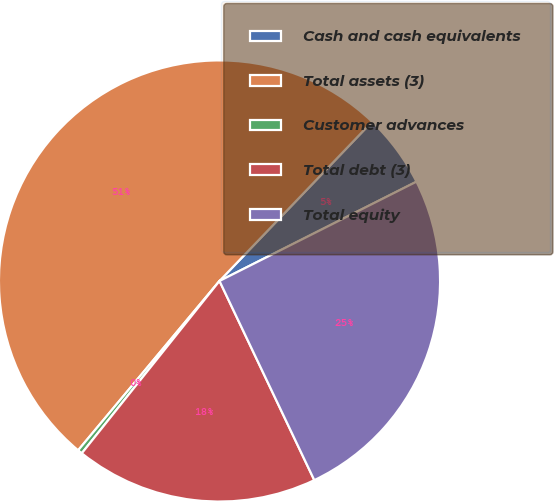Convert chart. <chart><loc_0><loc_0><loc_500><loc_500><pie_chart><fcel>Cash and cash equivalents<fcel>Total assets (3)<fcel>Customer advances<fcel>Total debt (3)<fcel>Total equity<nl><fcel>5.41%<fcel>51.08%<fcel>0.34%<fcel>17.8%<fcel>25.36%<nl></chart> 